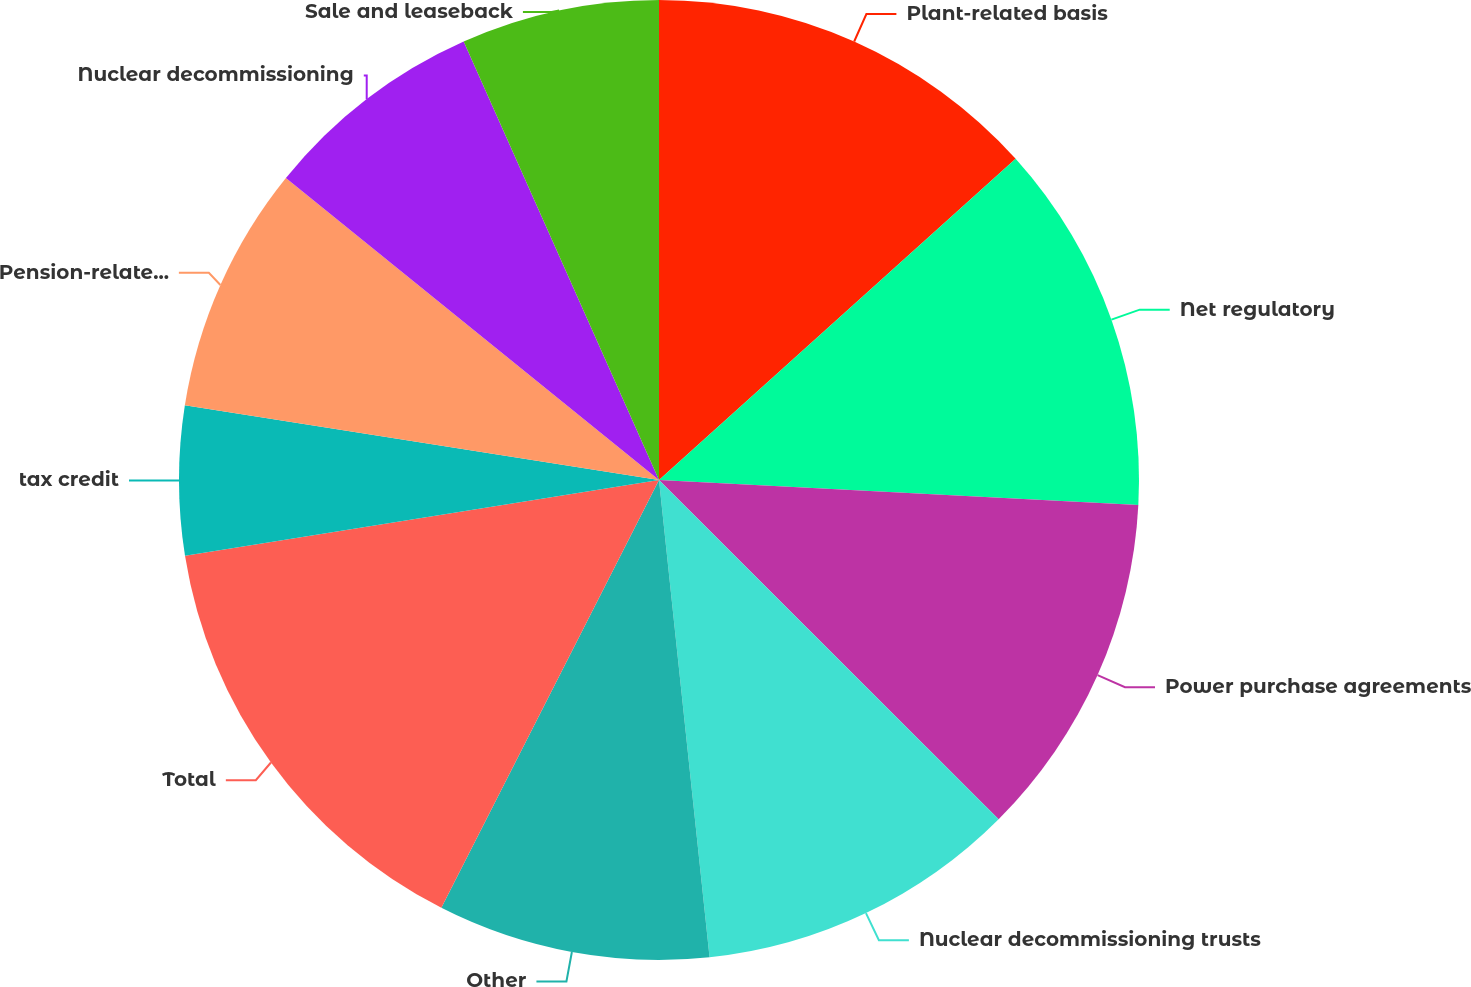<chart> <loc_0><loc_0><loc_500><loc_500><pie_chart><fcel>Plant-related basis<fcel>Net regulatory<fcel>Power purchase agreements<fcel>Nuclear decommissioning trusts<fcel>Other<fcel>Total<fcel>tax credit<fcel>Pension-related items<fcel>Nuclear decommissioning<fcel>Sale and leaseback<nl><fcel>13.33%<fcel>12.5%<fcel>11.66%<fcel>10.83%<fcel>9.17%<fcel>14.99%<fcel>5.01%<fcel>8.34%<fcel>7.5%<fcel>6.67%<nl></chart> 